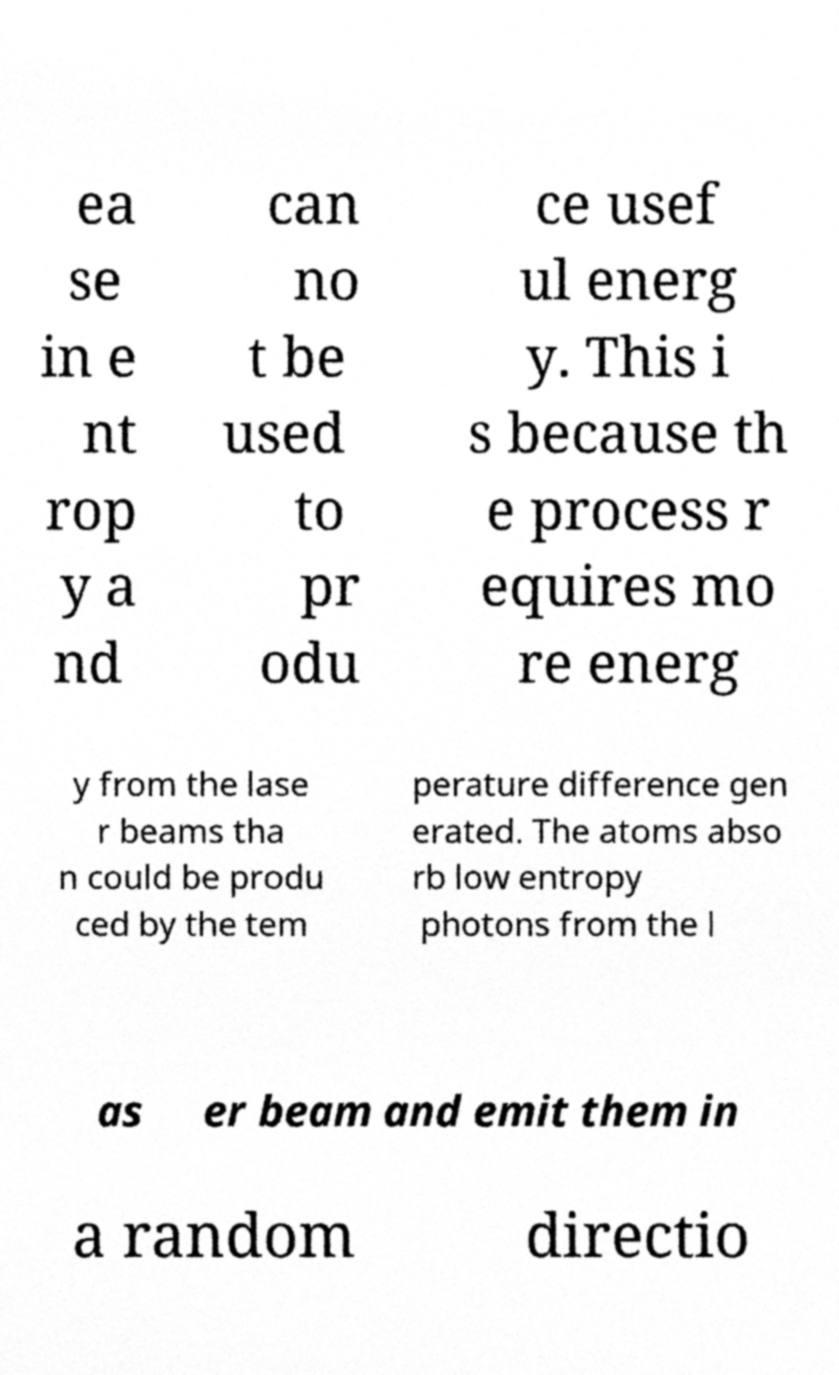Could you extract and type out the text from this image? ea se in e nt rop y a nd can no t be used to pr odu ce usef ul energ y. This i s because th e process r equires mo re energ y from the lase r beams tha n could be produ ced by the tem perature difference gen erated. The atoms abso rb low entropy photons from the l as er beam and emit them in a random directio 